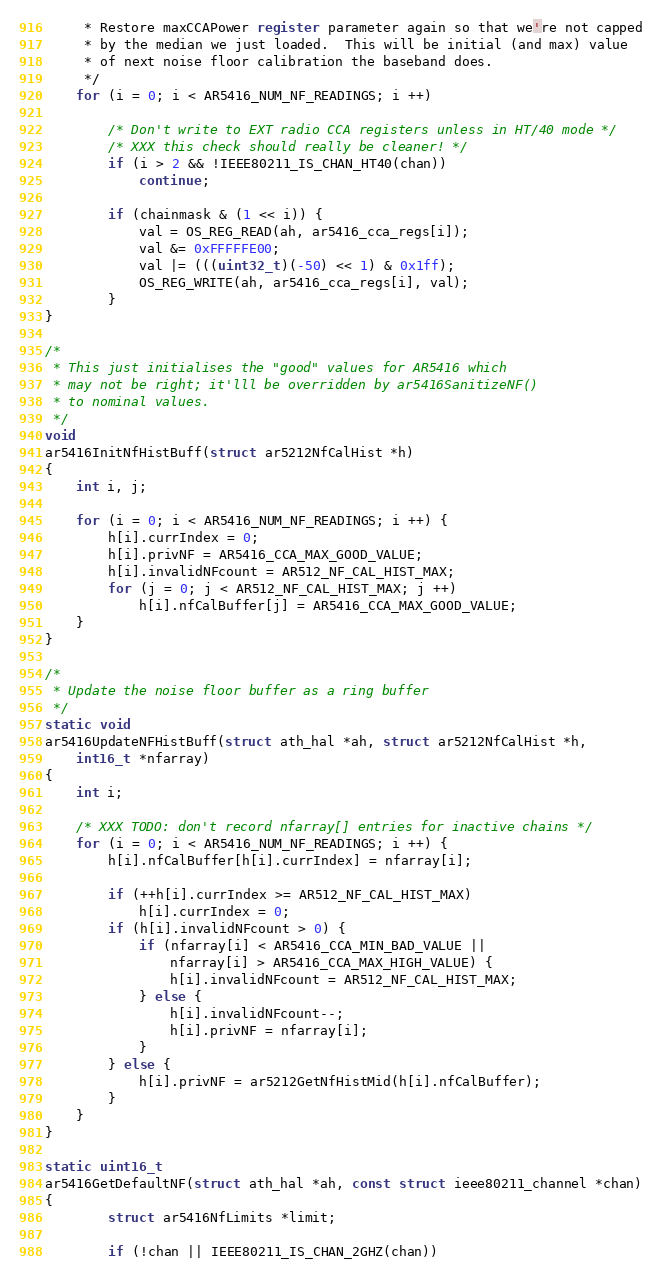Convert code to text. <code><loc_0><loc_0><loc_500><loc_500><_C_>	 * Restore maxCCAPower register parameter again so that we're not capped
	 * by the median we just loaded.  This will be initial (and max) value
	 * of next noise floor calibration the baseband does.  
	 */
	for (i = 0; i < AR5416_NUM_NF_READINGS; i ++)

		/* Don't write to EXT radio CCA registers unless in HT/40 mode */
		/* XXX this check should really be cleaner! */
		if (i > 2 && !IEEE80211_IS_CHAN_HT40(chan))
			continue;

		if (chainmask & (1 << i)) {	
			val = OS_REG_READ(ah, ar5416_cca_regs[i]);
			val &= 0xFFFFFE00;
			val |= (((uint32_t)(-50) << 1) & 0x1ff);
			OS_REG_WRITE(ah, ar5416_cca_regs[i], val);
		}
}

/*
 * This just initialises the "good" values for AR5416 which
 * may not be right; it'lll be overridden by ar5416SanitizeNF()
 * to nominal values.
 */
void
ar5416InitNfHistBuff(struct ar5212NfCalHist *h)
{
	int i, j;

	for (i = 0; i < AR5416_NUM_NF_READINGS; i ++) {
		h[i].currIndex = 0;
		h[i].privNF = AR5416_CCA_MAX_GOOD_VALUE;
		h[i].invalidNFcount = AR512_NF_CAL_HIST_MAX;
		for (j = 0; j < AR512_NF_CAL_HIST_MAX; j ++)
			h[i].nfCalBuffer[j] = AR5416_CCA_MAX_GOOD_VALUE;
	}
}

/*
 * Update the noise floor buffer as a ring buffer
 */
static void
ar5416UpdateNFHistBuff(struct ath_hal *ah, struct ar5212NfCalHist *h,
    int16_t *nfarray)
{
	int i;

	/* XXX TODO: don't record nfarray[] entries for inactive chains */
	for (i = 0; i < AR5416_NUM_NF_READINGS; i ++) {
		h[i].nfCalBuffer[h[i].currIndex] = nfarray[i];

		if (++h[i].currIndex >= AR512_NF_CAL_HIST_MAX)
			h[i].currIndex = 0;
		if (h[i].invalidNFcount > 0) {
			if (nfarray[i] < AR5416_CCA_MIN_BAD_VALUE ||
			    nfarray[i] > AR5416_CCA_MAX_HIGH_VALUE) {
				h[i].invalidNFcount = AR512_NF_CAL_HIST_MAX;
			} else {
				h[i].invalidNFcount--;
				h[i].privNF = nfarray[i];
			}
		} else {
			h[i].privNF = ar5212GetNfHistMid(h[i].nfCalBuffer);
		}
	}
}   

static uint16_t
ar5416GetDefaultNF(struct ath_hal *ah, const struct ieee80211_channel *chan)
{
        struct ar5416NfLimits *limit;

        if (!chan || IEEE80211_IS_CHAN_2GHZ(chan))</code> 